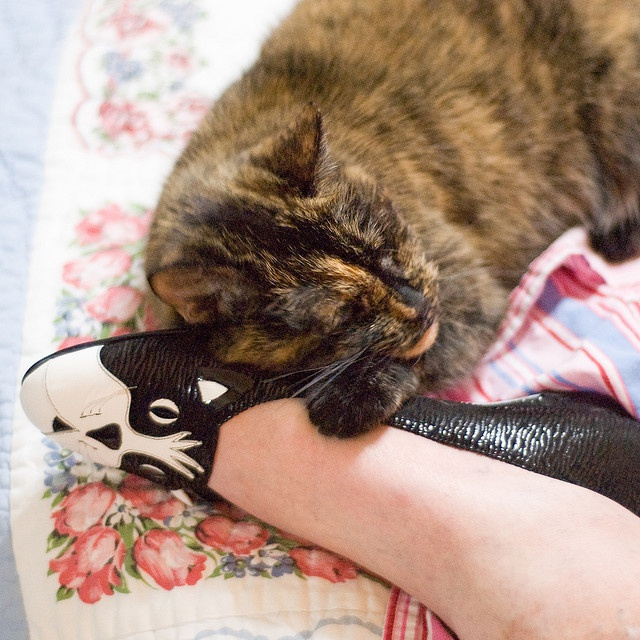Describe the objects in this image and their specific colors. I can see cat in lavender, gray, maroon, black, and tan tones and people in lavender, lightgray, tan, black, and salmon tones in this image. 